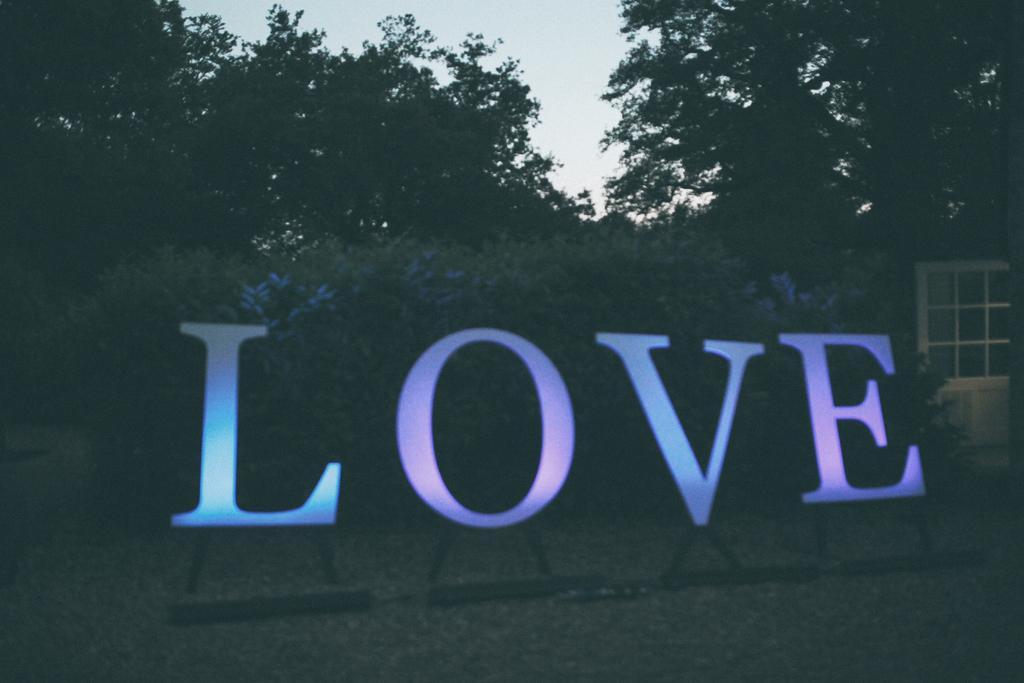Could you give a brief overview of what you see in this image? In this image, we can see letters stands and in the background, there are trees and we can see a door. At the top, there is sky. 